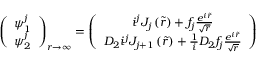Convert formula to latex. <formula><loc_0><loc_0><loc_500><loc_500>\left ( \begin{array} { c } { { \psi _ { 1 } ^ { j } } } \\ { { \psi _ { 2 } ^ { j } } } \end{array} \right ) _ { r \to \infty } = \left ( \begin{array} { c } { { i ^ { j } J _ { j } \left ( \tilde { r } \right ) + f _ { j } \frac { e ^ { i \tilde { r } } } { \sqrt { r } } } } \\ { { D _ { 2 } i ^ { j } J _ { j + 1 } \left ( \tilde { r } \right ) + \frac { 1 } { i } D _ { 2 } f _ { j } \frac { e ^ { i \tilde { r } } } { \sqrt { r } } } } \end{array} \right )</formula> 